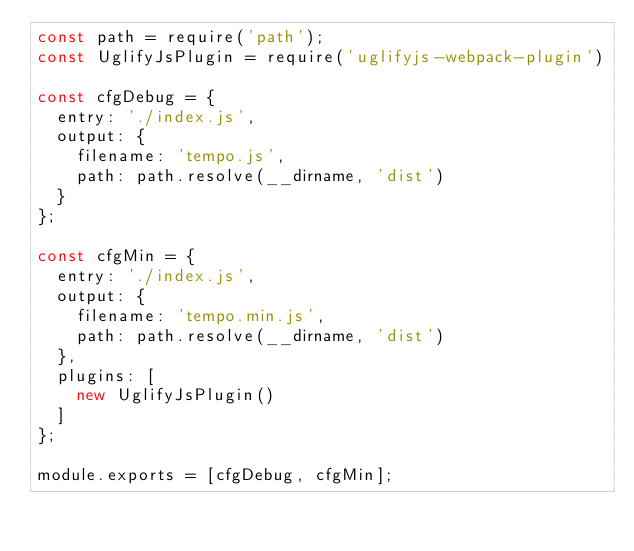<code> <loc_0><loc_0><loc_500><loc_500><_JavaScript_>const path = require('path');
const UglifyJsPlugin = require('uglifyjs-webpack-plugin')

const cfgDebug = {
  entry: './index.js',
  output: {
    filename: 'tempo.js',
    path: path.resolve(__dirname, 'dist')
  }
};

const cfgMin = {
  entry: './index.js',
  output: {
    filename: 'tempo.min.js',
    path: path.resolve(__dirname, 'dist')
  },
  plugins: [
    new UglifyJsPlugin()
  ]
};

module.exports = [cfgDebug, cfgMin];
</code> 